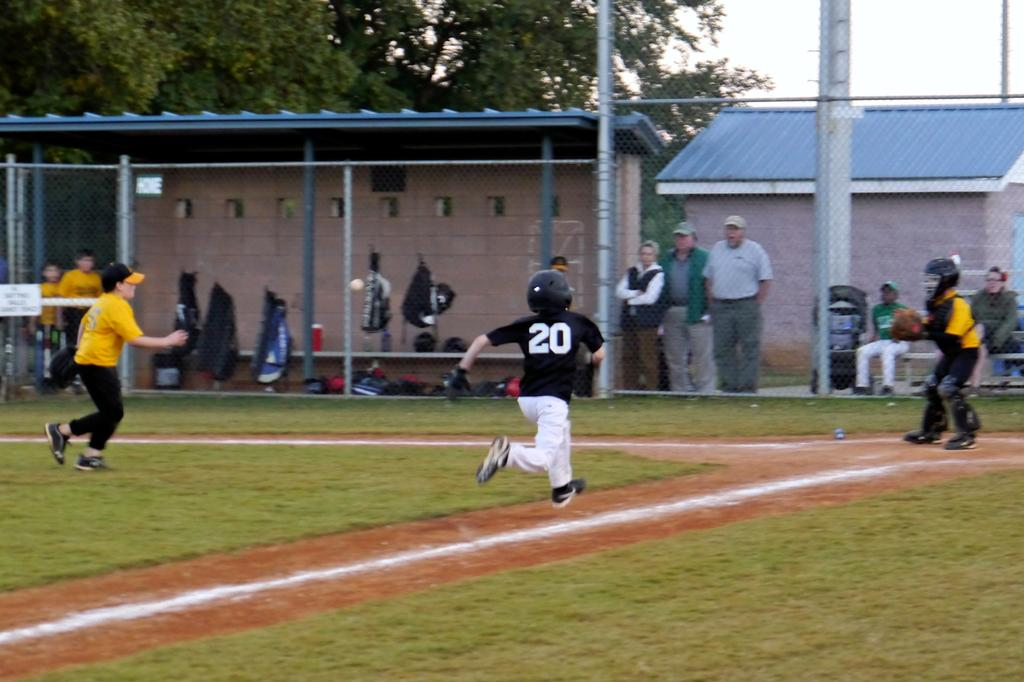<image>
Offer a succinct explanation of the picture presented. A little league game number twenty is taking a base. 